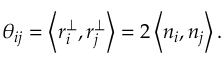<formula> <loc_0><loc_0><loc_500><loc_500>\theta _ { i j } = \left < { r _ { i } ^ { \perp } , r _ { j } ^ { \perp } } \right > = 2 \left < { n _ { i } , n _ { j } } \right > .</formula> 